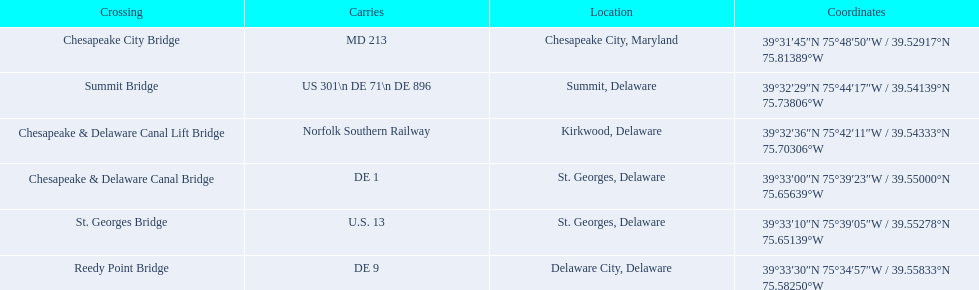Which crossing carries the most routes (e.g., de 1)? Summit Bridge. Write the full table. {'header': ['Crossing', 'Carries', 'Location', 'Coordinates'], 'rows': [['Chesapeake City Bridge', 'MD 213', 'Chesapeake City, Maryland', '39°31′45″N 75°48′50″W\ufeff / \ufeff39.52917°N 75.81389°W'], ['Summit Bridge', 'US 301\\n DE 71\\n DE 896', 'Summit, Delaware', '39°32′29″N 75°44′17″W\ufeff / \ufeff39.54139°N 75.73806°W'], ['Chesapeake & Delaware Canal Lift Bridge', 'Norfolk Southern Railway', 'Kirkwood, Delaware', '39°32′36″N 75°42′11″W\ufeff / \ufeff39.54333°N 75.70306°W'], ['Chesapeake & Delaware Canal Bridge', 'DE 1', 'St.\xa0Georges, Delaware', '39°33′00″N 75°39′23″W\ufeff / \ufeff39.55000°N 75.65639°W'], ['St.\xa0Georges Bridge', 'U.S.\xa013', 'St.\xa0Georges, Delaware', '39°33′10″N 75°39′05″W\ufeff / \ufeff39.55278°N 75.65139°W'], ['Reedy Point Bridge', 'DE\xa09', 'Delaware City, Delaware', '39°33′30″N 75°34′57″W\ufeff / \ufeff39.55833°N 75.58250°W']]} 